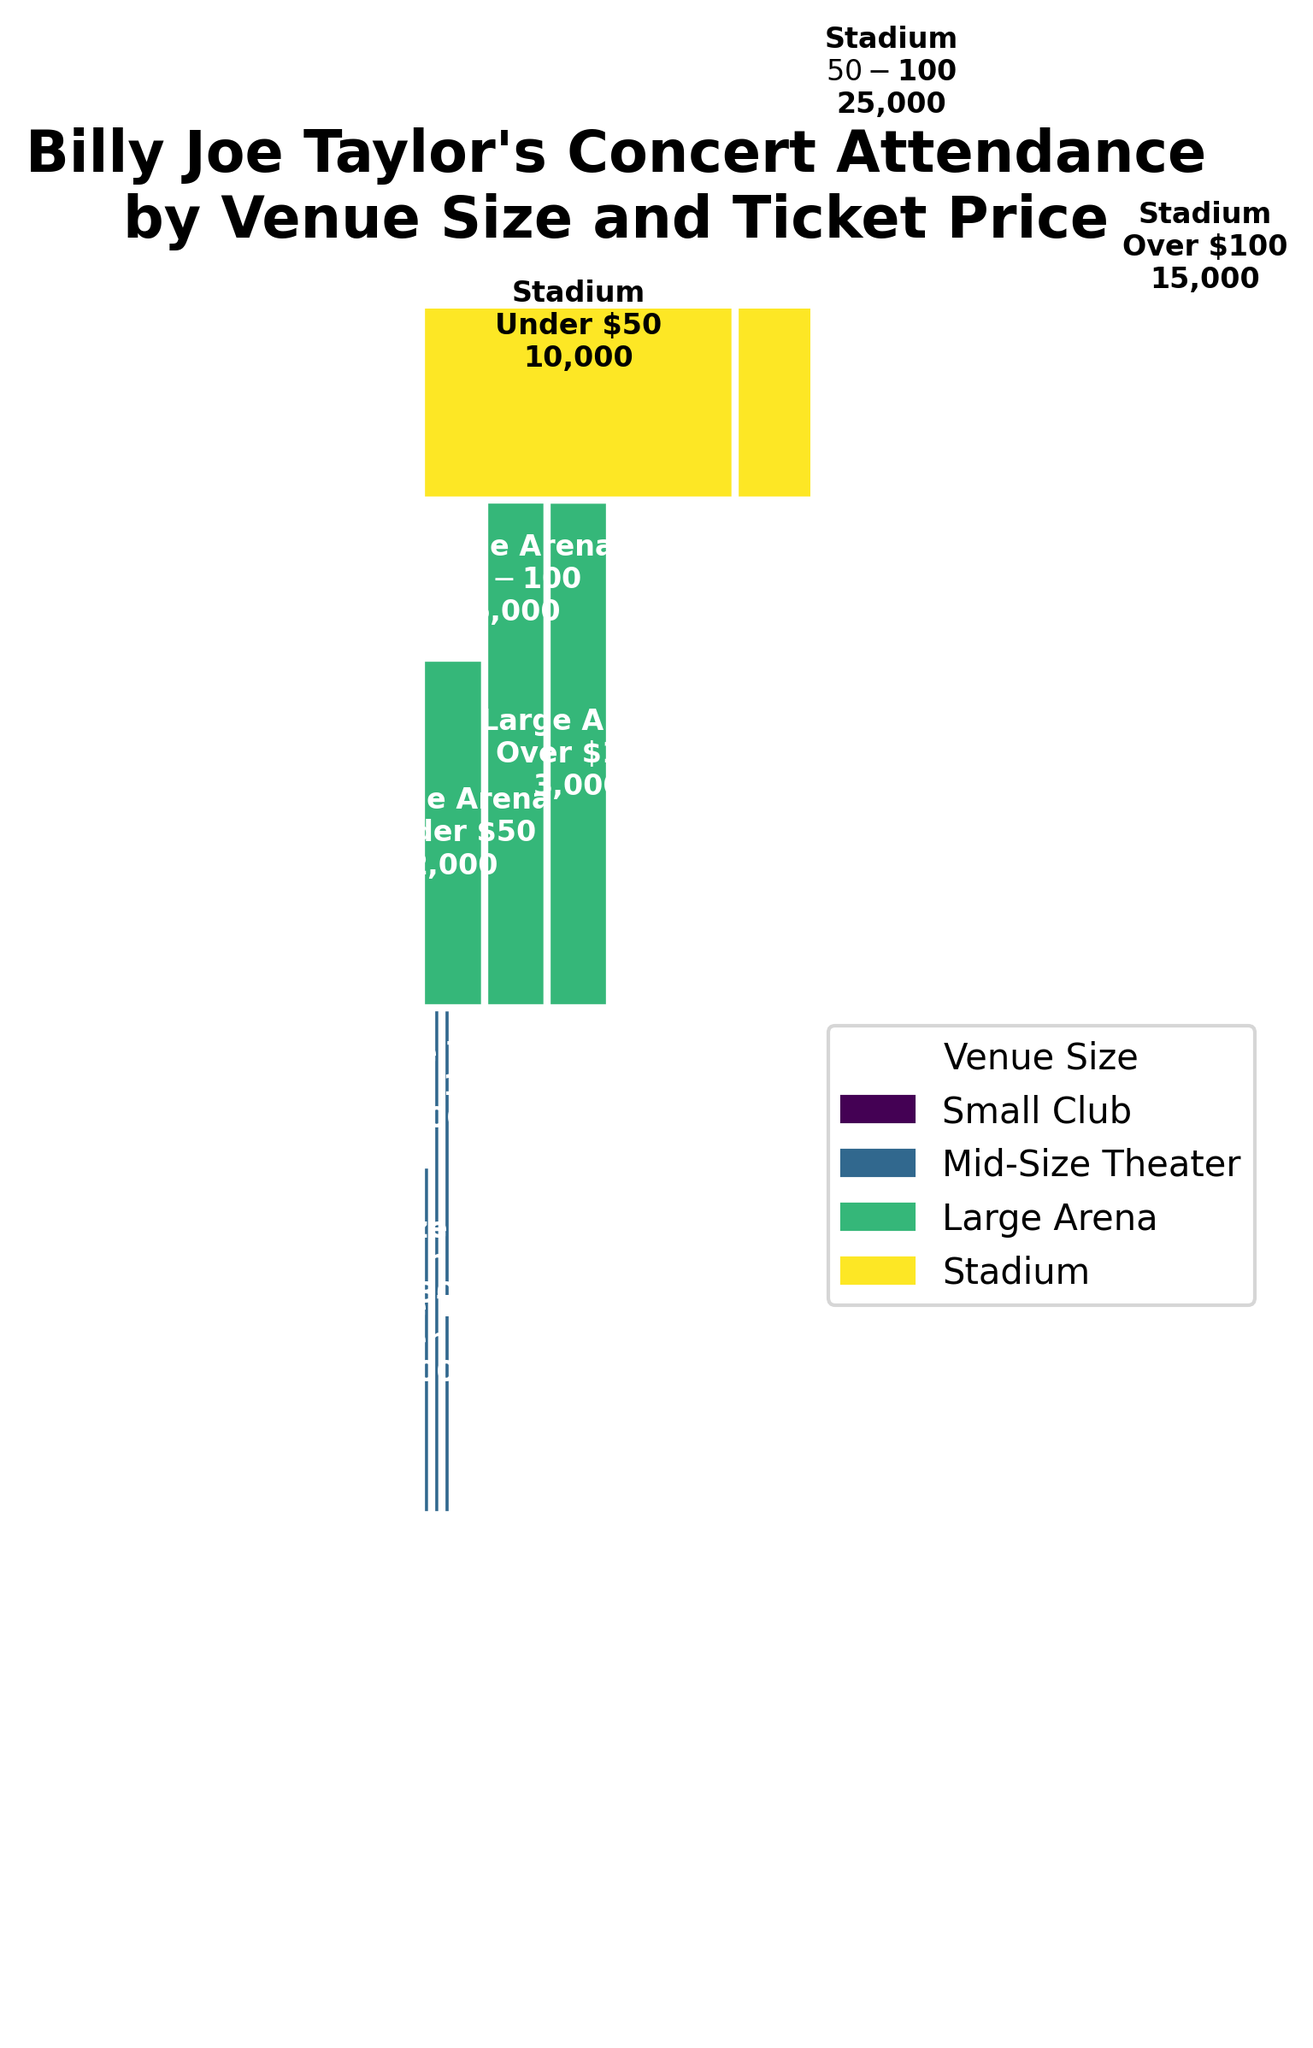How many people attended Billy Joe Taylor's concerts in Small Clubs? The attendance in Small Clubs is the sum of the attendance for all ticket price ranges. So, 150 (Under $50) + 200 ($50-$100) + 50 (Over $100).
Answer: 400 Which venue size had the highest total attendance? We sum the attendance for each venue size:
Small Club: 150 + 200 + 50 = 400
Mid-Size Theater: 500 + 800 + 300 = 1600
Large Arena: 2000 + 5000 + 3000 = 10000
Stadium: 10000 + 25000 + 15000 = 50000
The highest total attendance is for Stadium.
Answer: Stadium How does the attendance at Mid-Size Theaters for the $50-$100 ticket price compare to the attendance at Small Clubs for the same price range? We compare the attendance figures directly:
Mid-Size Theater attendance for $50-$100: 800
Small Club attendance for $50-$100: 200
Answer: 800 is greater than 200 What is the proportion of total attendance for concerts priced over $100? We need to find the total attendance for the 'Over $100' range and divide it by the total attendance.
Over $100: 50 (Small Club) + 300 (Mid-Size Theater) + 3000 (Large Arena) + 15000 (Stadium) = 18350
Total attendance: 67000
Proportion: 18350 / 67000 ≈ 0.274
Answer: 27.4% Which ticket price range had the lowest total attendance across all venue sizes? Sum the attendance for each ticket price range:
Under $50: 150 + 500 + 2000 + 10000 = 12650
$50-$100: 200 + 800 + 5000 + 25000 = 31000
Over $100: 50 + 300 + 3000 + 15000 = 18350
The lowest total attendance is for 'Under $50'.
Answer: Under $50 How does the total attendance for Large Arenas compare to Mid-Size Theaters? Sum the attendance for each of the two venue sizes and compare:
Large Arena: 2000 + 5000 + 3000 = 10000
Mid-Size Theater: 500 + 800 + 300 = 1600
Answer: 10000 is greater than 1600 